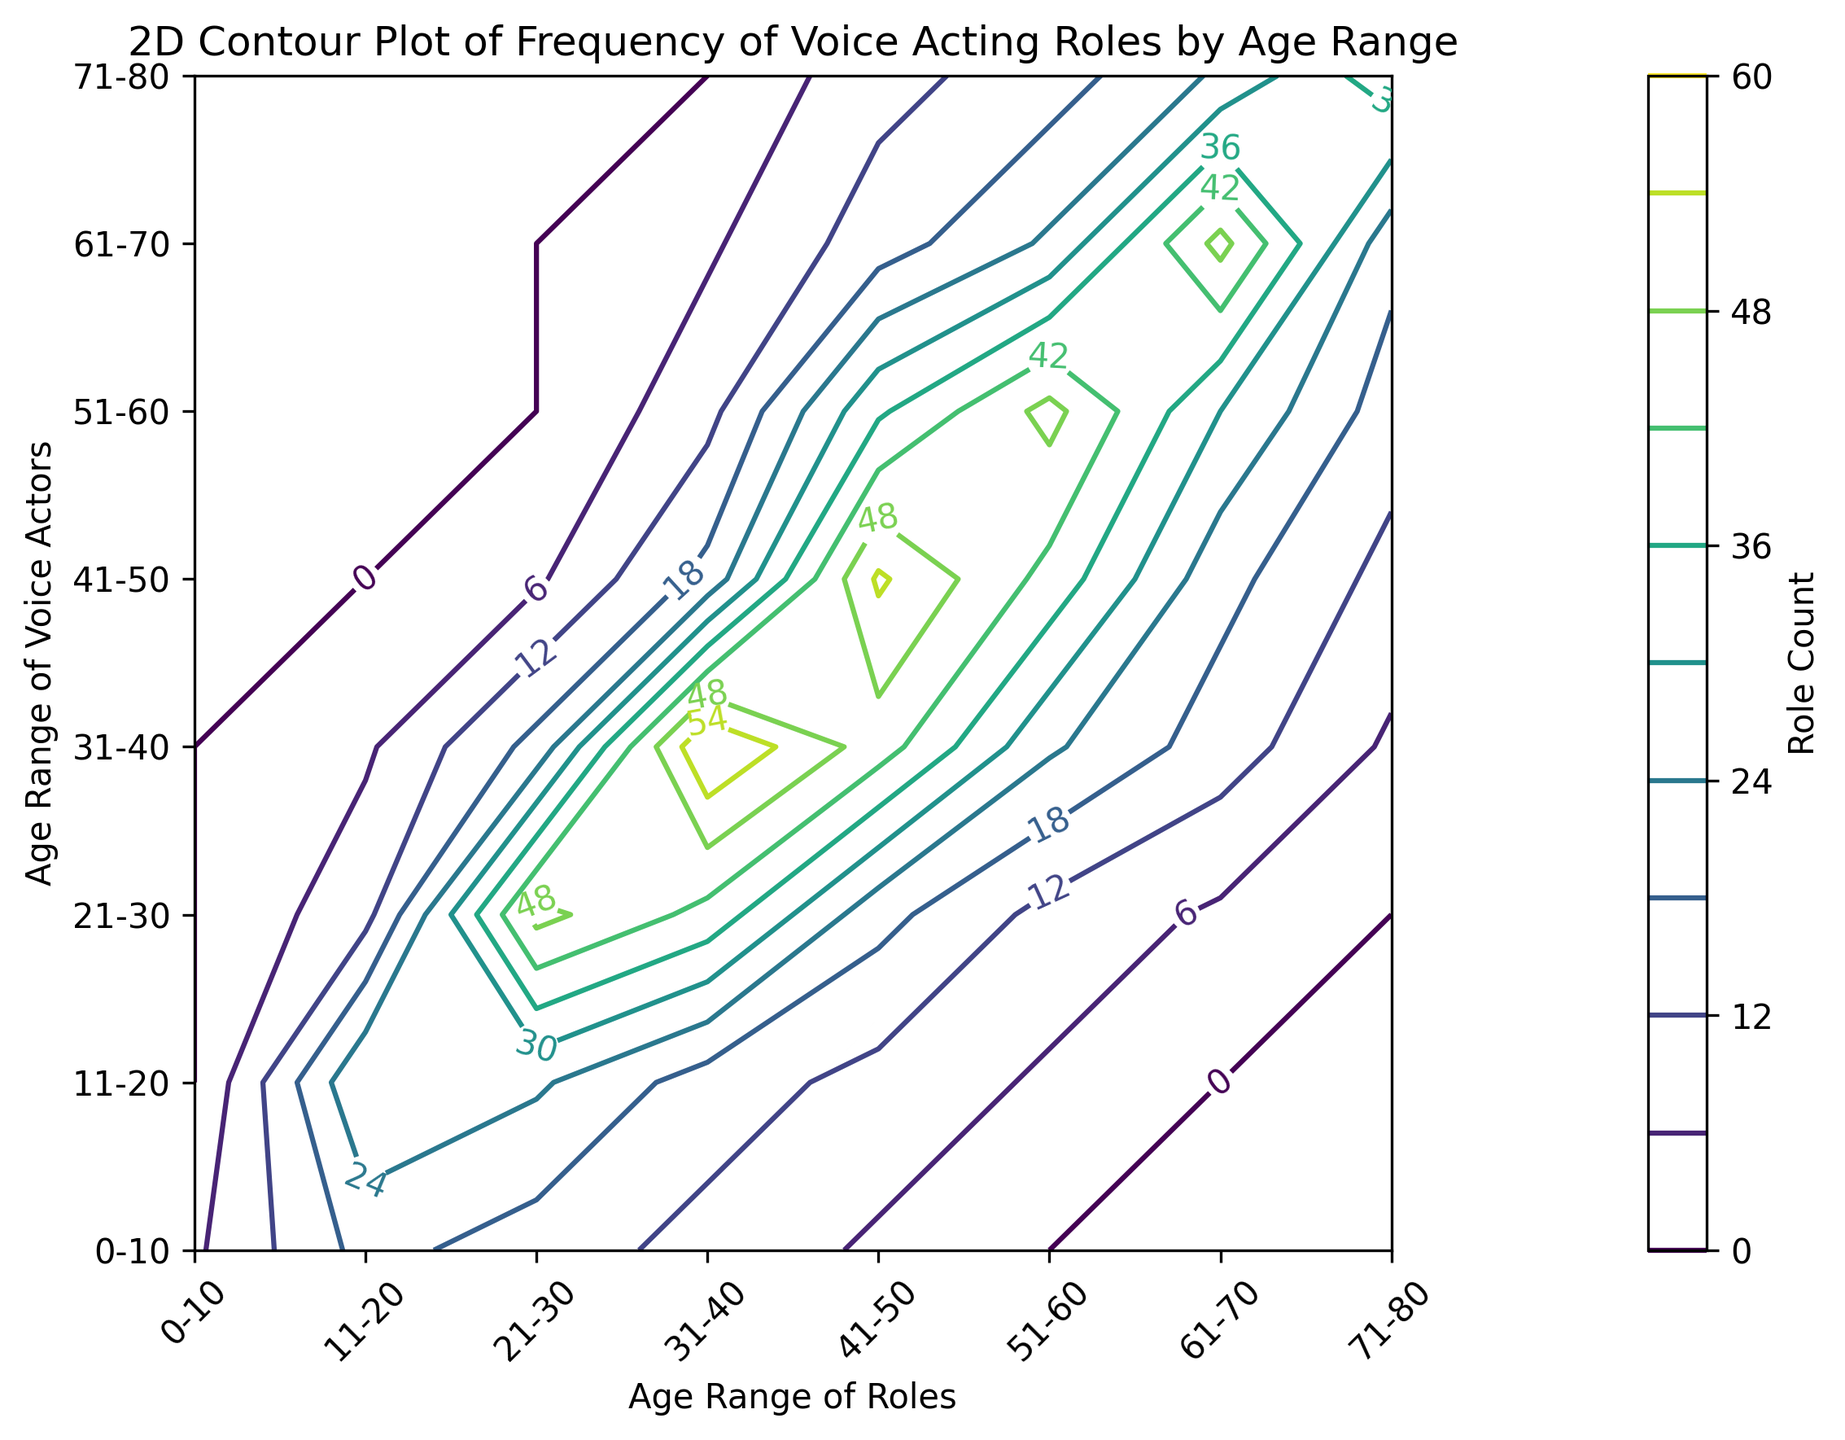what age range of voice actors has the highest number of roles for the 21-30 age range of roles? Look at the 21-30 column in the figure and find the highest value. The highest value is located at the intersection with the 21-30 age range of voice actors.
Answer: 50 Which age range of voice actors has more roles for the 41-50 age range of roles, the 31-40 range or the 21-30 range? Compare the values in the 41-50 column for the 31-40 and 21-30 age ranges. The value for the 31-40 range is 20, and the value for the 21-30 range is 20. Therefore, they are equal.
Answer: Equal What is the sum of roles for the age range 51-60 of voice actors for roles in the 31-40 and 41-50 age ranges? Find the values for the age range 51-60 of voice actors in the 31-40 and 41-50 columns and sum them up: 31-40 (10) + 41-50 (35) = 10 + 35 = 45.
Answer: 45 Considering the 61-70 age range of roles, does it contain more roles from voice actors aged 41-50 or 51-60? Look at the 61-70 column for the values at the intersections with the 41-50 and 51-60 rows. The values are 20 (41-50) and 30 (51-60). Comparing these, 51-60 has more roles.
Answer: 51-60 Is there any age range of voice actors that has a zero count of roles across all age ranges of roles? Check each row for any age range of voice actors to see if there is a row where all values are zero. None of the rows have all zeros; every age range has at least some roles.
Answer: No 